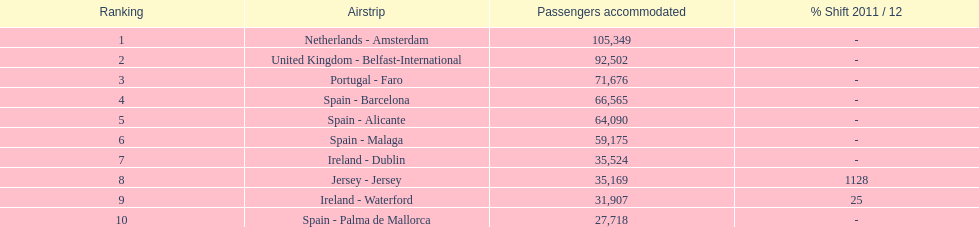Where is the most popular destination for passengers leaving london southend airport? Netherlands - Amsterdam. 